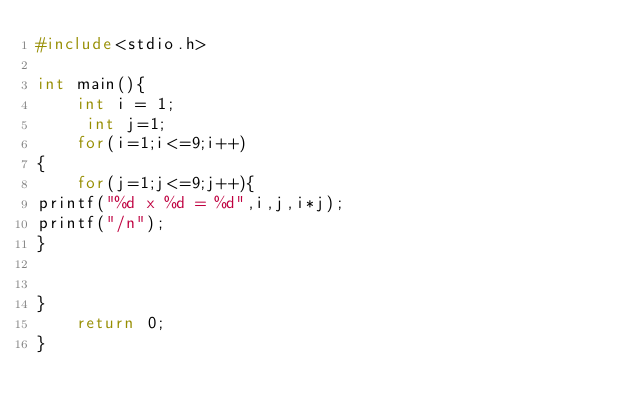<code> <loc_0><loc_0><loc_500><loc_500><_C_>#include<stdio.h>

int main(){
    int i = 1;
     int j=1;
    for(i=1;i<=9;i++)
{
    for(j=1;j<=9;j++){
printf("%d x %d = %d",i,j,i*j);
printf("/n");
}
    

}
    return 0;
}</code> 